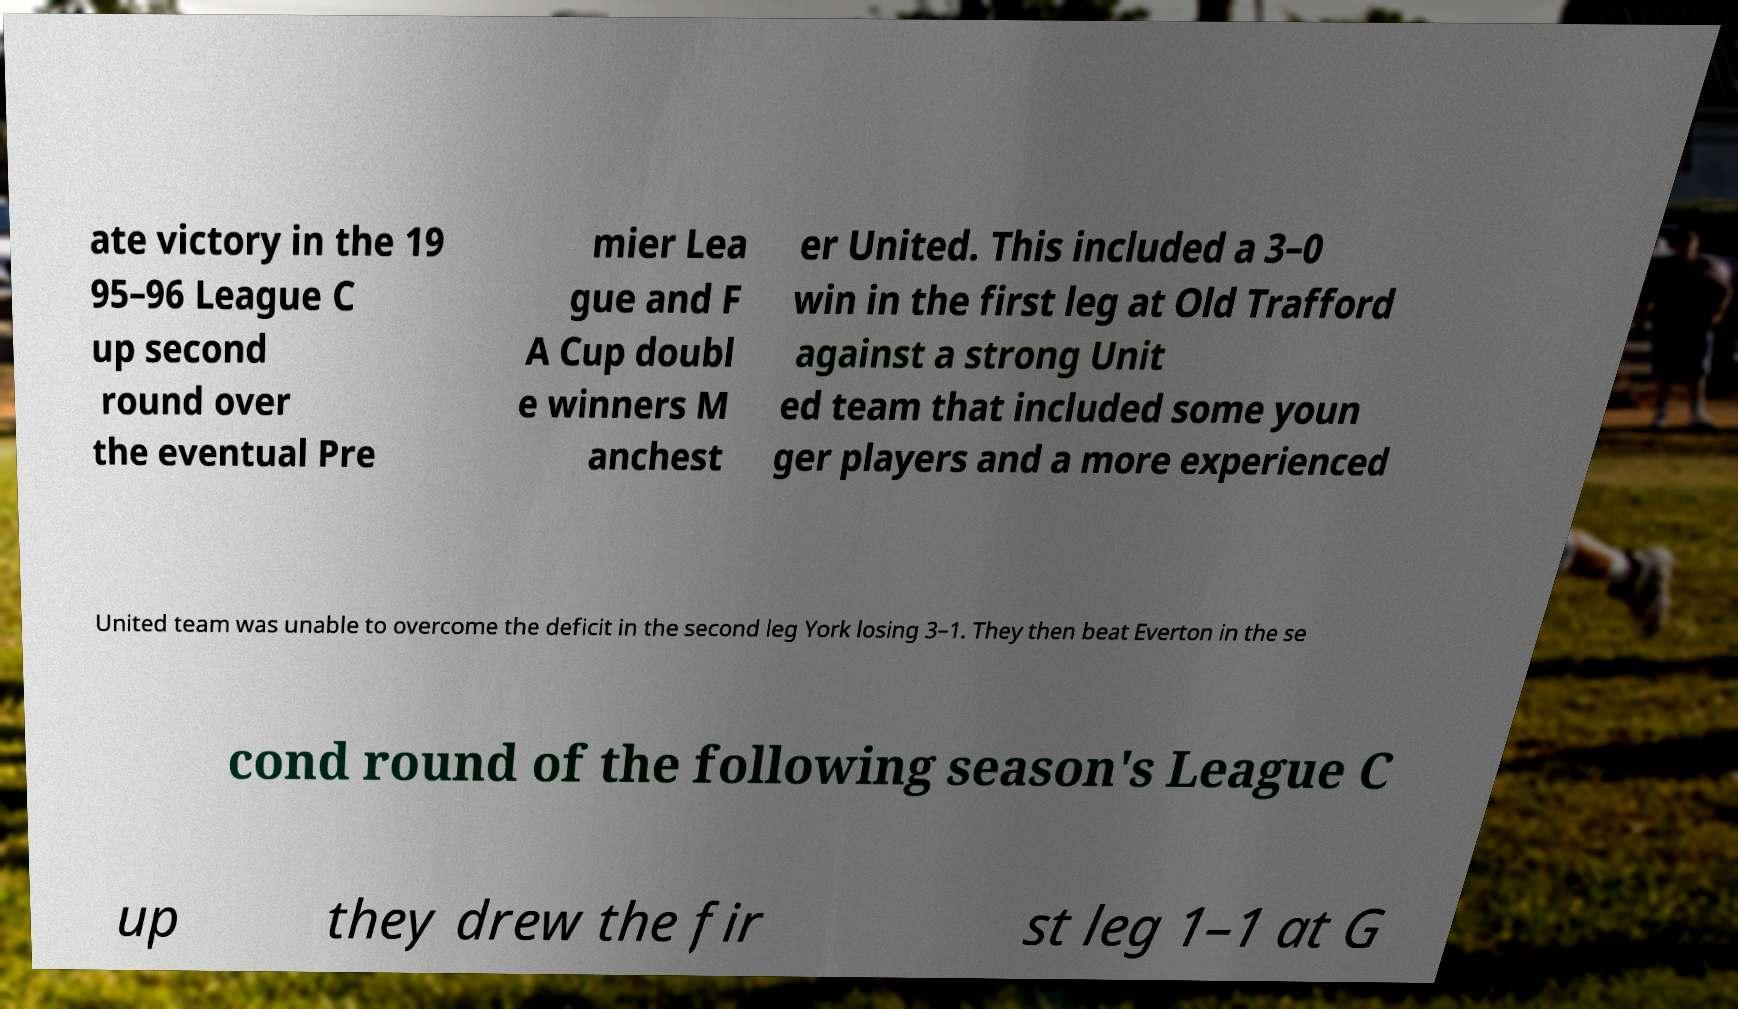For documentation purposes, I need the text within this image transcribed. Could you provide that? ate victory in the 19 95–96 League C up second round over the eventual Pre mier Lea gue and F A Cup doubl e winners M anchest er United. This included a 3–0 win in the first leg at Old Trafford against a strong Unit ed team that included some youn ger players and a more experienced United team was unable to overcome the deficit in the second leg York losing 3–1. They then beat Everton in the se cond round of the following season's League C up they drew the fir st leg 1–1 at G 